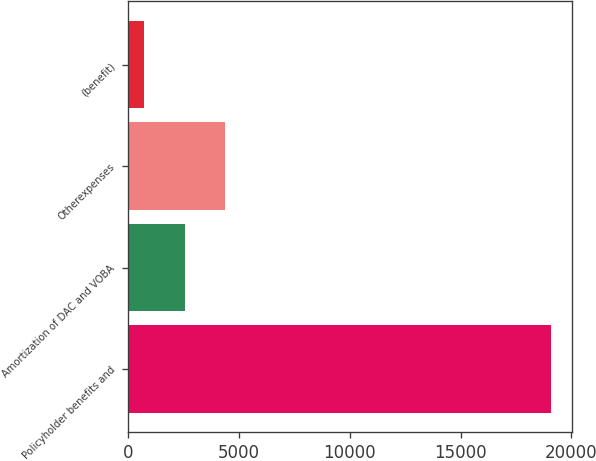Convert chart to OTSL. <chart><loc_0><loc_0><loc_500><loc_500><bar_chart><fcel>Policyholder benefits and<fcel>Amortization of DAC and VOBA<fcel>Otherexpenses<fcel>(benefit)<nl><fcel>19075<fcel>2547.4<fcel>4383.8<fcel>711<nl></chart> 